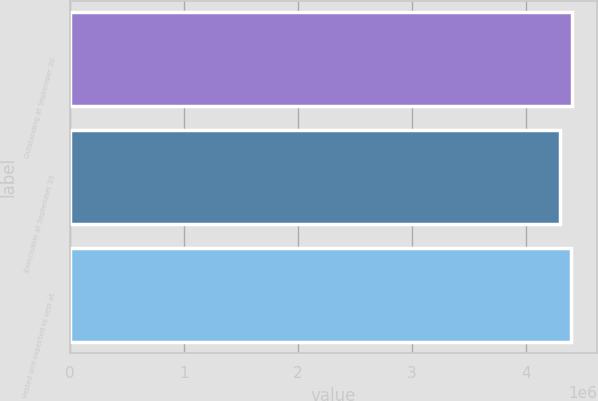Convert chart. <chart><loc_0><loc_0><loc_500><loc_500><bar_chart><fcel>Outstanding at September 30<fcel>Exercisable at September 30<fcel>Vested and expected to vest at<nl><fcel>4.40442e+06<fcel>4.29607e+06<fcel>4.39441e+06<nl></chart> 